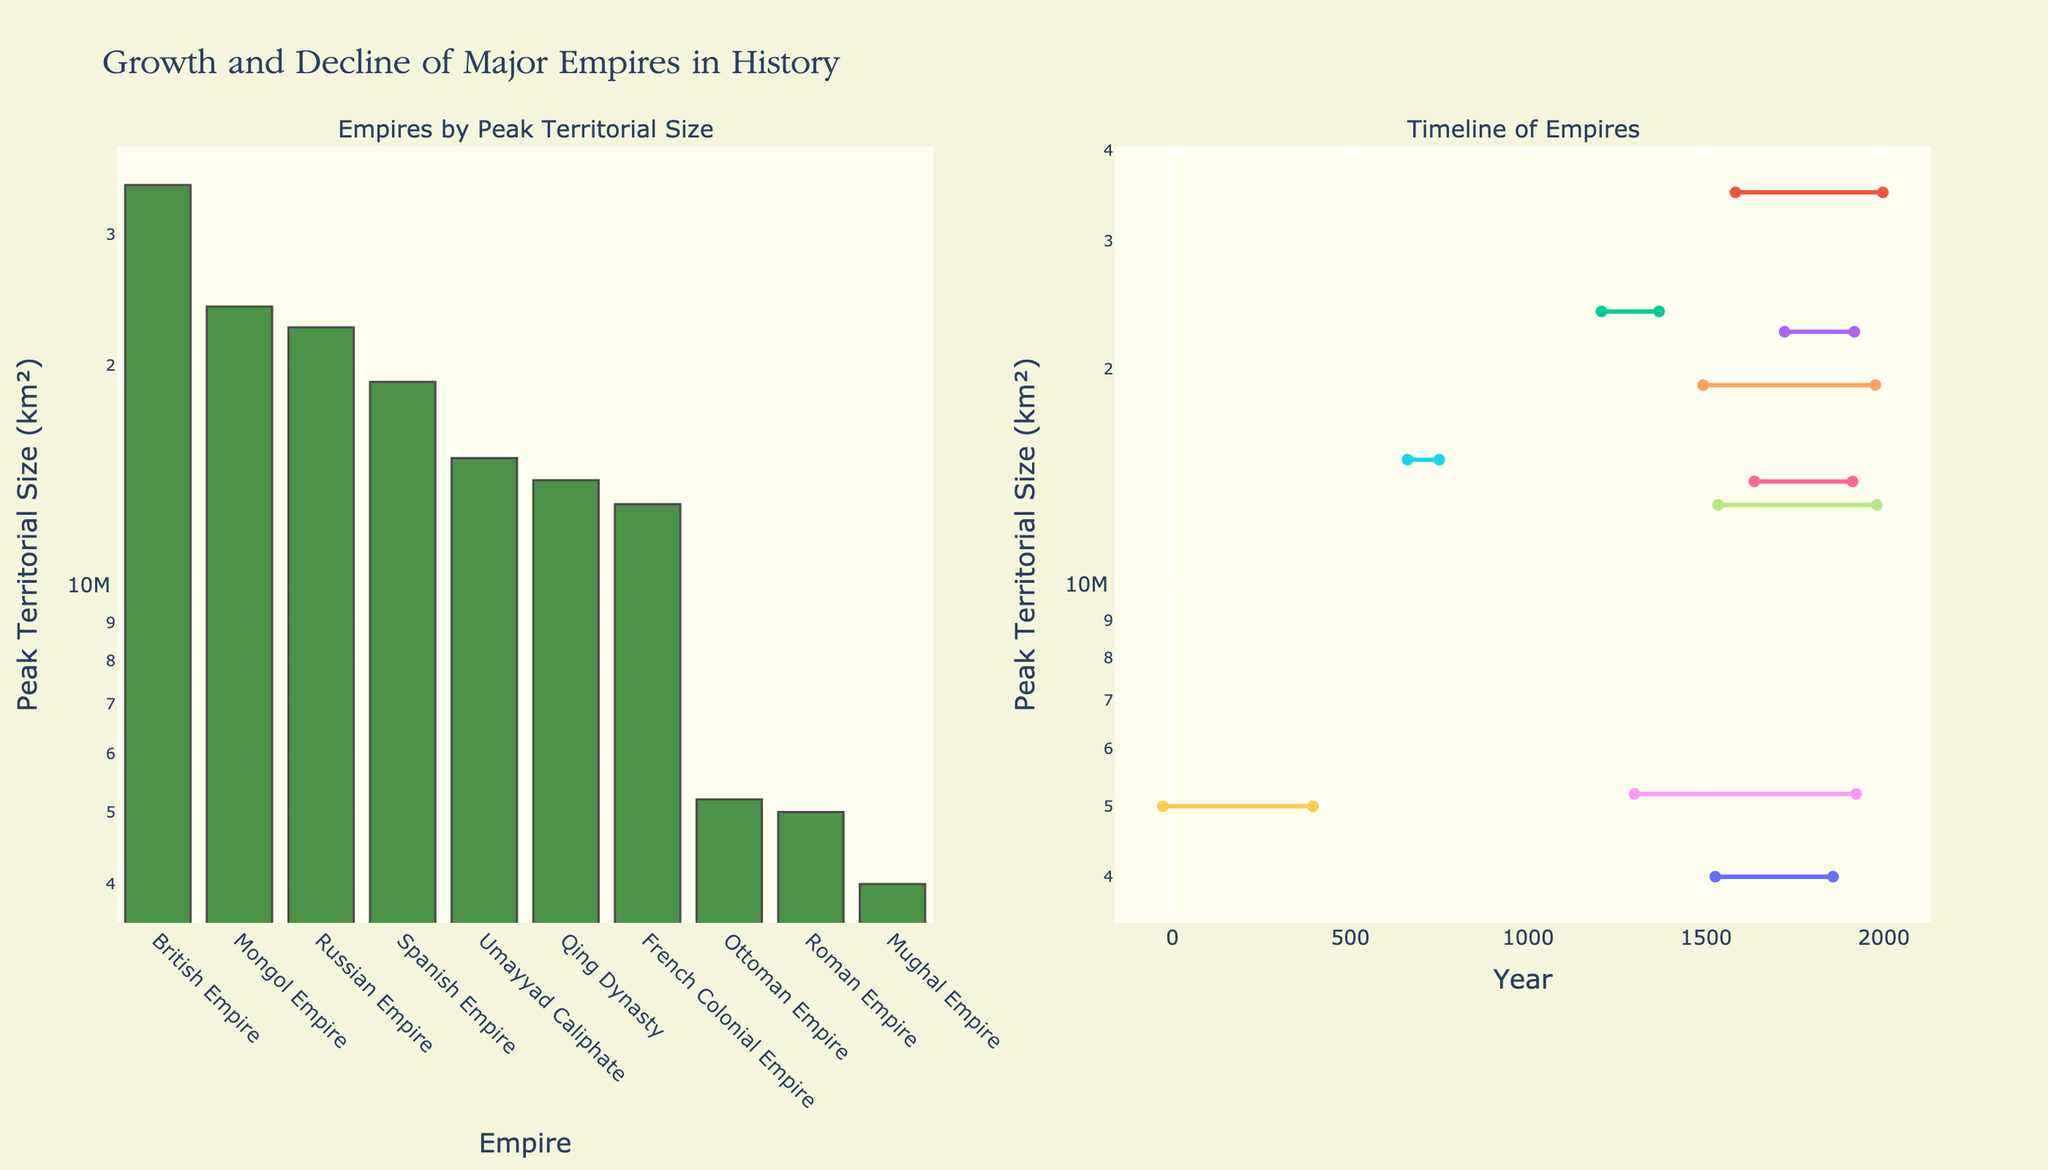What is the peak territorial size of the British Empire? The bar plot on the left shows the peak territorial size of each empire. The British Empire has the tallest bar among all, representing its peak size.
Answer: 35,000,000 km² Which empire had the largest peak territorial size on the bar chart? By examining the height of the bars, the British Empire is the tallest, indicating it had the largest peak territorial size.
Answer: British Empire What is the time range during which the Mongol Empire existed? On the scatter plot to the right, the Mongol Empire is listed among the timelines of other empires. The time range for the Mongol Empire is marked from 1206 to 1368.
Answer: 1206 - 1368 Compare the peak territorial sizes of the Mongol Empire and the Russian Empire. Which one was larger and by how much? The bars representing the peak sizes show that the Mongol Empire was 24,000,000 km², and the Russian Empire was 22,500,000 km². The difference is 24,000,000 - 22,500,000.
Answer: Mongol Empire by 1,500,000 km² What is the smallest peak territorial size among the empires and which empire does it belong to? The shortest bar in the bar plot represents the smallest peak territorial size. The Mughal Empire is the shortest with 4,000,000 km².
Answer: 4,000,000 km², Mughal Empire How many empires reached a peak territorial size of over 10,000,000 km²? Count the bars that reach above the 10,000,000 km² mark on the y-axis. The empires are the British, Mongol, Spanish, Russian, French Colonial, and Umayyad Caliphate, totaling six empires.
Answer: 6 empires What is the difference in peak territorial size between the Umayyad Caliphate and the Ottoman Empire? The bar heights show that the Umayyad Caliphate had 15,000,000 km², and the Ottoman Empire had 5,200,000 km². The difference is 15,000,000 - 5,200,000.
Answer: 9,800,000 km² Which empire lasted the longest according to the timeline scatter plot, and how many years did it last? The length of the lines on the scatter plot indicates the duration of each empire. The British Empire line is the longest, running from 1583 to 1997, lasting 414 years.
Answer: British Empire, 414 years Examining both plots, name one empire that had a moderate peak size but remained in power for an extensive period. The Ottoman Empire had a moderate peak size of 5,200,000 km² and existed from 1299 to 1922, lasting for approximately 623 years.
Answer: Ottoman Empire 